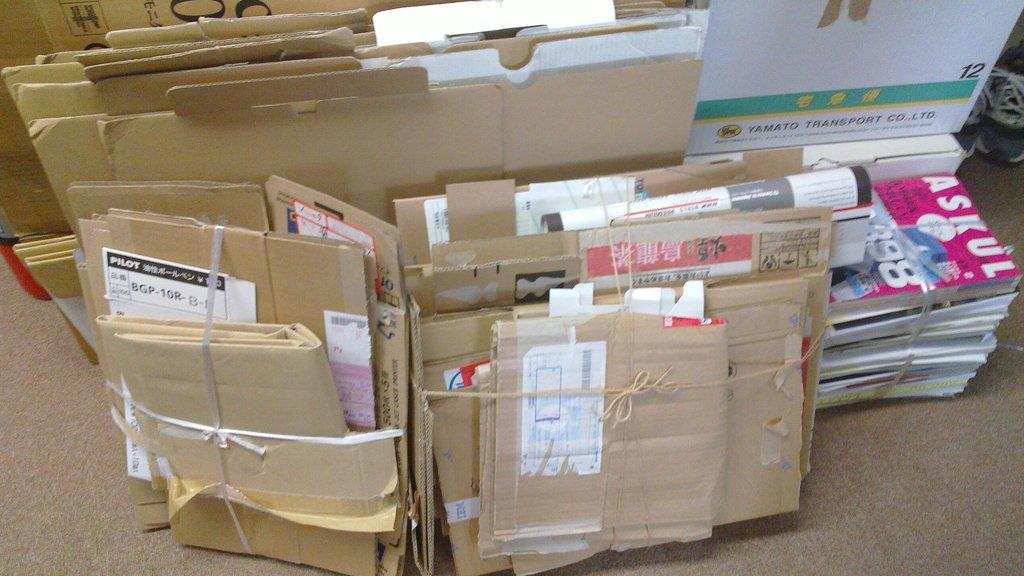<image>
Create a compact narrative representing the image presented. A stack of folded carboard boxes tied up with string and a book that says Askul. 